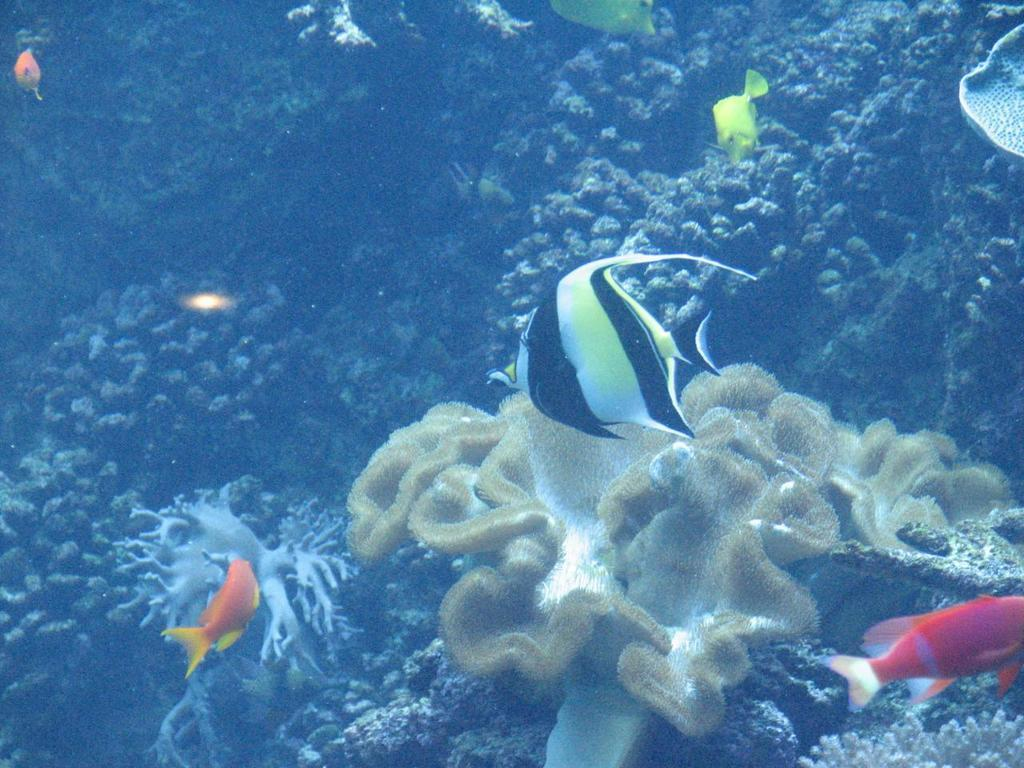What type of animals can be seen in the image? There are colorful fishes in the image. Where are the fishes located? The fishes are underwater in the image. What else can be seen in the underwater environment? There are plants and objects visible in the image. What type of vegetation is present in the image? There are bushes in the image. How does the rainstorm affect the bushes in the image? There is no rainstorm present in the image, so its effect on the bushes cannot be determined. 